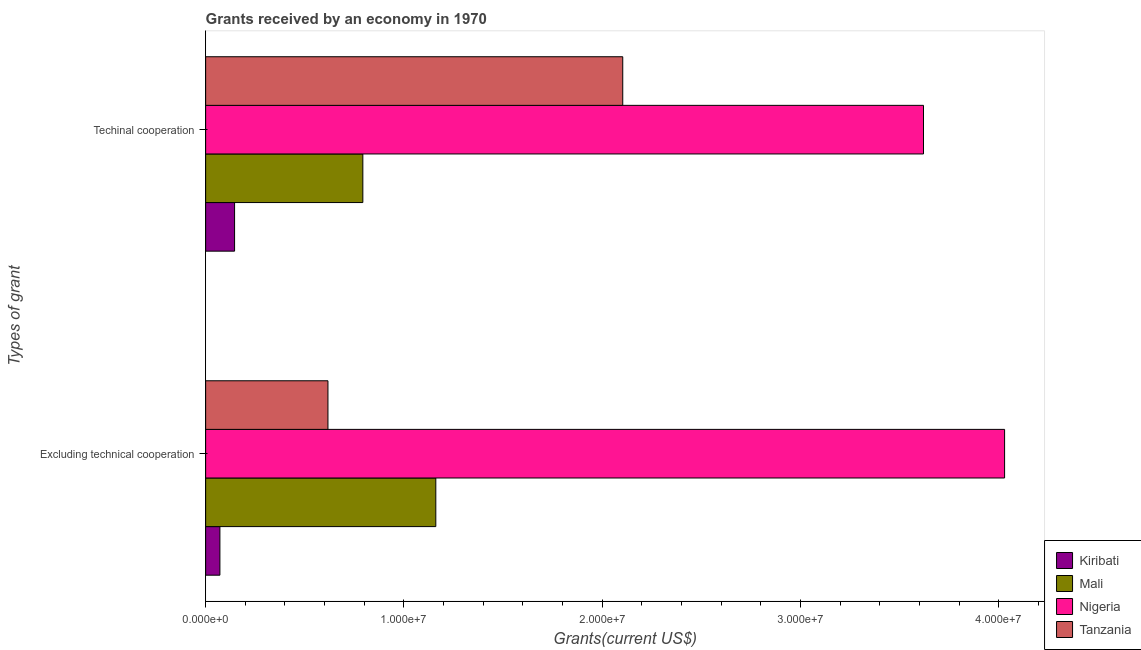Are the number of bars per tick equal to the number of legend labels?
Your answer should be very brief. Yes. How many bars are there on the 1st tick from the top?
Keep it short and to the point. 4. What is the label of the 2nd group of bars from the top?
Offer a very short reply. Excluding technical cooperation. What is the amount of grants received(including technical cooperation) in Tanzania?
Offer a very short reply. 2.10e+07. Across all countries, what is the maximum amount of grants received(excluding technical cooperation)?
Your answer should be very brief. 4.03e+07. Across all countries, what is the minimum amount of grants received(excluding technical cooperation)?
Offer a terse response. 7.20e+05. In which country was the amount of grants received(excluding technical cooperation) maximum?
Your answer should be compact. Nigeria. In which country was the amount of grants received(excluding technical cooperation) minimum?
Offer a terse response. Kiribati. What is the total amount of grants received(excluding technical cooperation) in the graph?
Give a very brief answer. 5.88e+07. What is the difference between the amount of grants received(excluding technical cooperation) in Tanzania and that in Nigeria?
Offer a very short reply. -3.41e+07. What is the difference between the amount of grants received(excluding technical cooperation) in Nigeria and the amount of grants received(including technical cooperation) in Mali?
Offer a very short reply. 3.24e+07. What is the average amount of grants received(including technical cooperation) per country?
Provide a short and direct response. 1.67e+07. What is the difference between the amount of grants received(including technical cooperation) and amount of grants received(excluding technical cooperation) in Mali?
Keep it short and to the point. -3.68e+06. What is the ratio of the amount of grants received(including technical cooperation) in Tanzania to that in Nigeria?
Your answer should be very brief. 0.58. Is the amount of grants received(including technical cooperation) in Mali less than that in Tanzania?
Your answer should be compact. Yes. What does the 1st bar from the top in Excluding technical cooperation represents?
Ensure brevity in your answer.  Tanzania. What does the 2nd bar from the bottom in Techinal cooperation represents?
Keep it short and to the point. Mali. Are all the bars in the graph horizontal?
Offer a very short reply. Yes. What is the difference between two consecutive major ticks on the X-axis?
Your answer should be compact. 1.00e+07. How are the legend labels stacked?
Keep it short and to the point. Vertical. What is the title of the graph?
Offer a very short reply. Grants received by an economy in 1970. Does "Bhutan" appear as one of the legend labels in the graph?
Make the answer very short. No. What is the label or title of the X-axis?
Keep it short and to the point. Grants(current US$). What is the label or title of the Y-axis?
Offer a terse response. Types of grant. What is the Grants(current US$) of Kiribati in Excluding technical cooperation?
Your response must be concise. 7.20e+05. What is the Grants(current US$) in Mali in Excluding technical cooperation?
Give a very brief answer. 1.16e+07. What is the Grants(current US$) of Nigeria in Excluding technical cooperation?
Your response must be concise. 4.03e+07. What is the Grants(current US$) of Tanzania in Excluding technical cooperation?
Provide a succinct answer. 6.17e+06. What is the Grants(current US$) of Kiribati in Techinal cooperation?
Ensure brevity in your answer.  1.46e+06. What is the Grants(current US$) of Mali in Techinal cooperation?
Keep it short and to the point. 7.93e+06. What is the Grants(current US$) in Nigeria in Techinal cooperation?
Your response must be concise. 3.62e+07. What is the Grants(current US$) of Tanzania in Techinal cooperation?
Offer a very short reply. 2.10e+07. Across all Types of grant, what is the maximum Grants(current US$) of Kiribati?
Keep it short and to the point. 1.46e+06. Across all Types of grant, what is the maximum Grants(current US$) of Mali?
Your answer should be compact. 1.16e+07. Across all Types of grant, what is the maximum Grants(current US$) of Nigeria?
Provide a succinct answer. 4.03e+07. Across all Types of grant, what is the maximum Grants(current US$) of Tanzania?
Make the answer very short. 2.10e+07. Across all Types of grant, what is the minimum Grants(current US$) in Kiribati?
Provide a short and direct response. 7.20e+05. Across all Types of grant, what is the minimum Grants(current US$) of Mali?
Keep it short and to the point. 7.93e+06. Across all Types of grant, what is the minimum Grants(current US$) in Nigeria?
Provide a succinct answer. 3.62e+07. Across all Types of grant, what is the minimum Grants(current US$) in Tanzania?
Offer a terse response. 6.17e+06. What is the total Grants(current US$) in Kiribati in the graph?
Offer a terse response. 2.18e+06. What is the total Grants(current US$) in Mali in the graph?
Ensure brevity in your answer.  1.95e+07. What is the total Grants(current US$) of Nigeria in the graph?
Provide a succinct answer. 7.65e+07. What is the total Grants(current US$) of Tanzania in the graph?
Provide a short and direct response. 2.72e+07. What is the difference between the Grants(current US$) of Kiribati in Excluding technical cooperation and that in Techinal cooperation?
Provide a short and direct response. -7.40e+05. What is the difference between the Grants(current US$) of Mali in Excluding technical cooperation and that in Techinal cooperation?
Ensure brevity in your answer.  3.68e+06. What is the difference between the Grants(current US$) in Nigeria in Excluding technical cooperation and that in Techinal cooperation?
Provide a succinct answer. 4.09e+06. What is the difference between the Grants(current US$) in Tanzania in Excluding technical cooperation and that in Techinal cooperation?
Make the answer very short. -1.49e+07. What is the difference between the Grants(current US$) of Kiribati in Excluding technical cooperation and the Grants(current US$) of Mali in Techinal cooperation?
Make the answer very short. -7.21e+06. What is the difference between the Grants(current US$) of Kiribati in Excluding technical cooperation and the Grants(current US$) of Nigeria in Techinal cooperation?
Provide a short and direct response. -3.55e+07. What is the difference between the Grants(current US$) of Kiribati in Excluding technical cooperation and the Grants(current US$) of Tanzania in Techinal cooperation?
Provide a short and direct response. -2.03e+07. What is the difference between the Grants(current US$) in Mali in Excluding technical cooperation and the Grants(current US$) in Nigeria in Techinal cooperation?
Give a very brief answer. -2.46e+07. What is the difference between the Grants(current US$) in Mali in Excluding technical cooperation and the Grants(current US$) in Tanzania in Techinal cooperation?
Offer a very short reply. -9.43e+06. What is the difference between the Grants(current US$) in Nigeria in Excluding technical cooperation and the Grants(current US$) in Tanzania in Techinal cooperation?
Offer a very short reply. 1.93e+07. What is the average Grants(current US$) in Kiribati per Types of grant?
Provide a short and direct response. 1.09e+06. What is the average Grants(current US$) in Mali per Types of grant?
Give a very brief answer. 9.77e+06. What is the average Grants(current US$) in Nigeria per Types of grant?
Your answer should be compact. 3.83e+07. What is the average Grants(current US$) in Tanzania per Types of grant?
Keep it short and to the point. 1.36e+07. What is the difference between the Grants(current US$) in Kiribati and Grants(current US$) in Mali in Excluding technical cooperation?
Make the answer very short. -1.09e+07. What is the difference between the Grants(current US$) of Kiribati and Grants(current US$) of Nigeria in Excluding technical cooperation?
Provide a short and direct response. -3.96e+07. What is the difference between the Grants(current US$) in Kiribati and Grants(current US$) in Tanzania in Excluding technical cooperation?
Your answer should be compact. -5.45e+06. What is the difference between the Grants(current US$) in Mali and Grants(current US$) in Nigeria in Excluding technical cooperation?
Your response must be concise. -2.87e+07. What is the difference between the Grants(current US$) in Mali and Grants(current US$) in Tanzania in Excluding technical cooperation?
Provide a succinct answer. 5.44e+06. What is the difference between the Grants(current US$) of Nigeria and Grants(current US$) of Tanzania in Excluding technical cooperation?
Keep it short and to the point. 3.41e+07. What is the difference between the Grants(current US$) in Kiribati and Grants(current US$) in Mali in Techinal cooperation?
Provide a succinct answer. -6.47e+06. What is the difference between the Grants(current US$) in Kiribati and Grants(current US$) in Nigeria in Techinal cooperation?
Your answer should be compact. -3.48e+07. What is the difference between the Grants(current US$) of Kiribati and Grants(current US$) of Tanzania in Techinal cooperation?
Offer a very short reply. -1.96e+07. What is the difference between the Grants(current US$) in Mali and Grants(current US$) in Nigeria in Techinal cooperation?
Offer a very short reply. -2.83e+07. What is the difference between the Grants(current US$) of Mali and Grants(current US$) of Tanzania in Techinal cooperation?
Ensure brevity in your answer.  -1.31e+07. What is the difference between the Grants(current US$) in Nigeria and Grants(current US$) in Tanzania in Techinal cooperation?
Provide a short and direct response. 1.52e+07. What is the ratio of the Grants(current US$) of Kiribati in Excluding technical cooperation to that in Techinal cooperation?
Provide a succinct answer. 0.49. What is the ratio of the Grants(current US$) in Mali in Excluding technical cooperation to that in Techinal cooperation?
Offer a very short reply. 1.46. What is the ratio of the Grants(current US$) in Nigeria in Excluding technical cooperation to that in Techinal cooperation?
Provide a short and direct response. 1.11. What is the ratio of the Grants(current US$) of Tanzania in Excluding technical cooperation to that in Techinal cooperation?
Offer a very short reply. 0.29. What is the difference between the highest and the second highest Grants(current US$) in Kiribati?
Offer a terse response. 7.40e+05. What is the difference between the highest and the second highest Grants(current US$) of Mali?
Keep it short and to the point. 3.68e+06. What is the difference between the highest and the second highest Grants(current US$) in Nigeria?
Offer a very short reply. 4.09e+06. What is the difference between the highest and the second highest Grants(current US$) in Tanzania?
Provide a succinct answer. 1.49e+07. What is the difference between the highest and the lowest Grants(current US$) in Kiribati?
Offer a very short reply. 7.40e+05. What is the difference between the highest and the lowest Grants(current US$) in Mali?
Keep it short and to the point. 3.68e+06. What is the difference between the highest and the lowest Grants(current US$) in Nigeria?
Provide a succinct answer. 4.09e+06. What is the difference between the highest and the lowest Grants(current US$) in Tanzania?
Your response must be concise. 1.49e+07. 